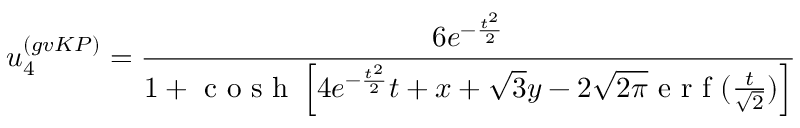<formula> <loc_0><loc_0><loc_500><loc_500>u _ { 4 } ^ { ( g v K P ) } = \frac { 6 e ^ { - \frac { t ^ { 2 } } { 2 } } } { 1 + c o s h \left [ 4 e ^ { - \frac { t ^ { 2 } } { 2 } } t + x + \sqrt { 3 } y - 2 \sqrt { 2 \pi } e r f ( \frac { t } { \sqrt { 2 } } ) \right ] }</formula> 